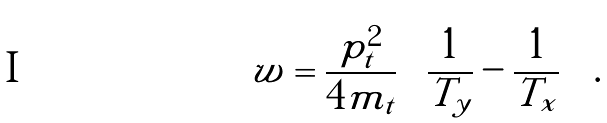<formula> <loc_0><loc_0><loc_500><loc_500>w = \frac { p _ { t } ^ { 2 } } { 4 m _ { t } } \left ( \frac { 1 } { T _ { y } } - \frac { 1 } { T _ { x } } \right ) \, .</formula> 